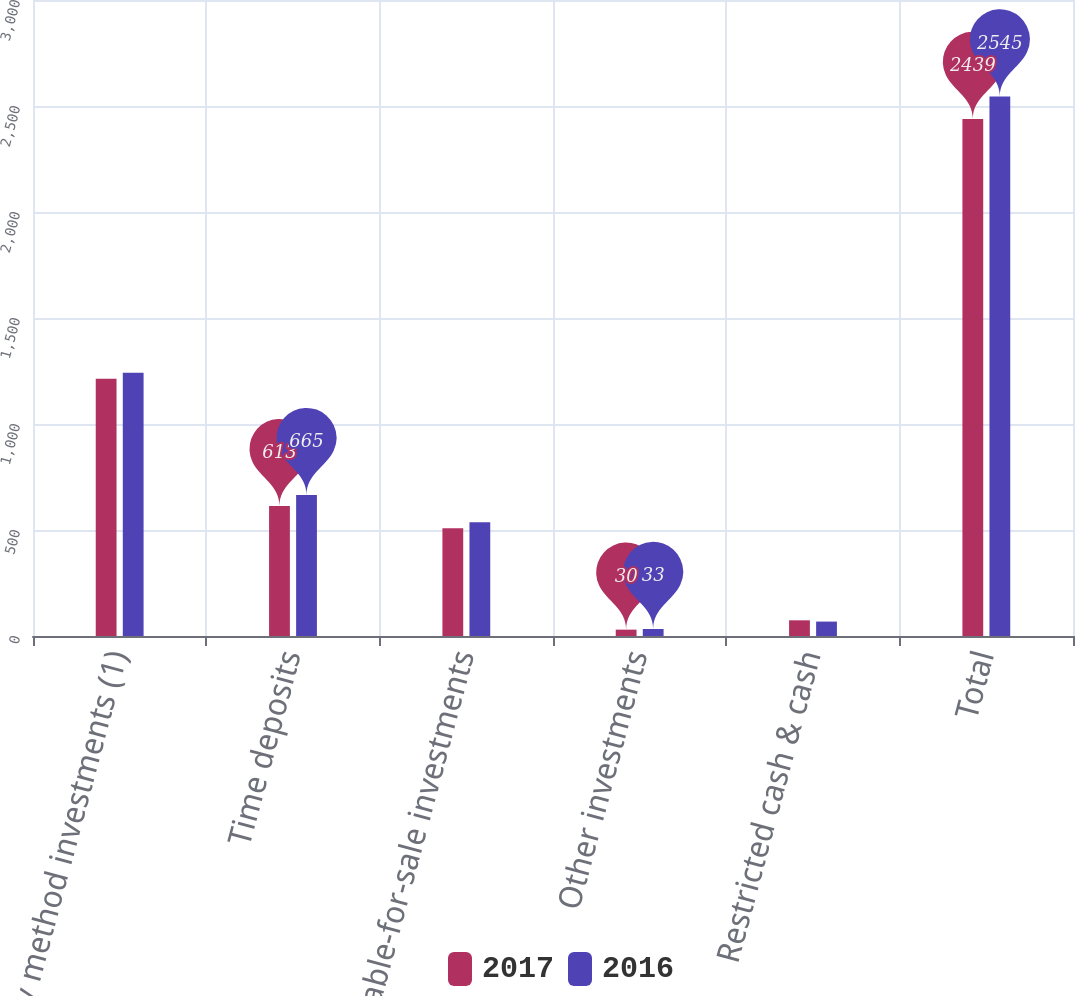Convert chart. <chart><loc_0><loc_0><loc_500><loc_500><stacked_bar_chart><ecel><fcel>Equity method investments (1)<fcel>Time deposits<fcel>Available-for-sale investments<fcel>Other investments<fcel>Restricted cash & cash<fcel>Total<nl><fcel>2017<fcel>1214<fcel>613<fcel>508<fcel>30<fcel>74<fcel>2439<nl><fcel>2016<fcel>1242<fcel>665<fcel>537<fcel>33<fcel>68<fcel>2545<nl></chart> 